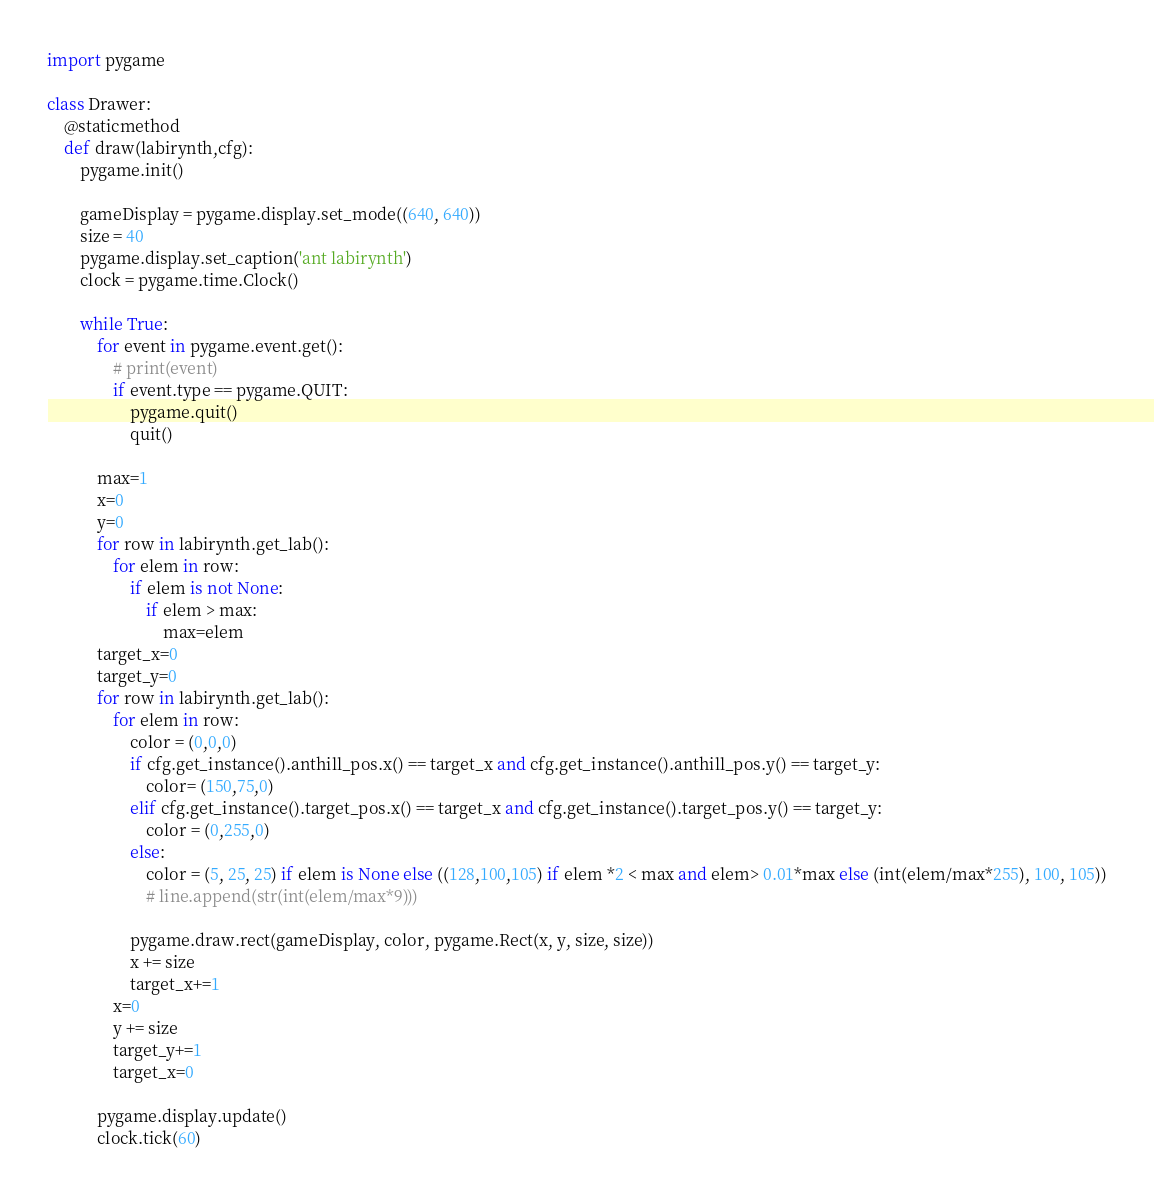<code> <loc_0><loc_0><loc_500><loc_500><_Python_>import pygame

class Drawer:
    @staticmethod
    def draw(labirynth,cfg):
        pygame.init()

        gameDisplay = pygame.display.set_mode((640, 640))
        size = 40
        pygame.display.set_caption('ant labirynth')
        clock = pygame.time.Clock()

        while True:
            for event in pygame.event.get():
                # print(event)
                if event.type == pygame.QUIT:
                    pygame.quit()
                    quit()

            max=1
            x=0
            y=0
            for row in labirynth.get_lab():
                for elem in row:
                    if elem is not None:
                        if elem > max:
                            max=elem
            target_x=0
            target_y=0
            for row in labirynth.get_lab():
                for elem in row:
                    color = (0,0,0)
                    if cfg.get_instance().anthill_pos.x() == target_x and cfg.get_instance().anthill_pos.y() == target_y:
                        color= (150,75,0)
                    elif cfg.get_instance().target_pos.x() == target_x and cfg.get_instance().target_pos.y() == target_y:
                        color = (0,255,0)
                    else:
                        color = (5, 25, 25) if elem is None else ((128,100,105) if elem *2 < max and elem> 0.01*max else (int(elem/max*255), 100, 105))
                        # line.append(str(int(elem/max*9)))
                    
                    pygame.draw.rect(gameDisplay, color, pygame.Rect(x, y, size, size))
                    x += size
                    target_x+=1
                x=0
                y += size
                target_y+=1
                target_x=0

            pygame.display.update()
            clock.tick(60)
</code> 